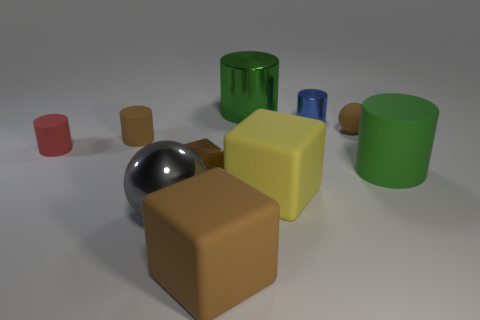Subtract all small rubber cylinders. How many cylinders are left? 3 Subtract 5 cylinders. How many cylinders are left? 0 Subtract all blocks. How many objects are left? 7 Subtract all cyan blocks. How many green cylinders are left? 2 Subtract all brown spheres. How many spheres are left? 1 Subtract all tiny green metal cylinders. Subtract all tiny red matte cylinders. How many objects are left? 9 Add 3 large green rubber cylinders. How many large green rubber cylinders are left? 4 Add 1 purple metal spheres. How many purple metal spheres exist? 1 Subtract 0 green cubes. How many objects are left? 10 Subtract all gray balls. Subtract all blue blocks. How many balls are left? 1 